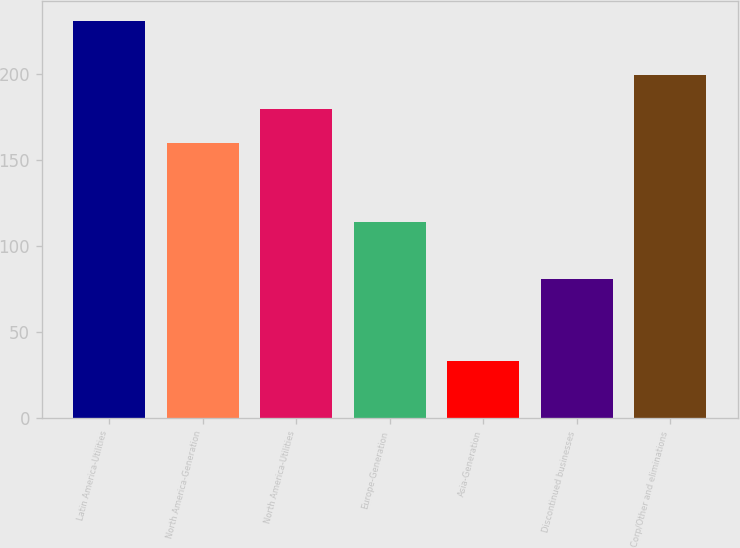<chart> <loc_0><loc_0><loc_500><loc_500><bar_chart><fcel>Latin America-Utilities<fcel>North America-Generation<fcel>North America-Utilities<fcel>Europe-Generation<fcel>Asia-Generation<fcel>Discontinued businesses<fcel>Corp/Other and eliminations<nl><fcel>231<fcel>160<fcel>179.8<fcel>114<fcel>33<fcel>81<fcel>199.6<nl></chart> 